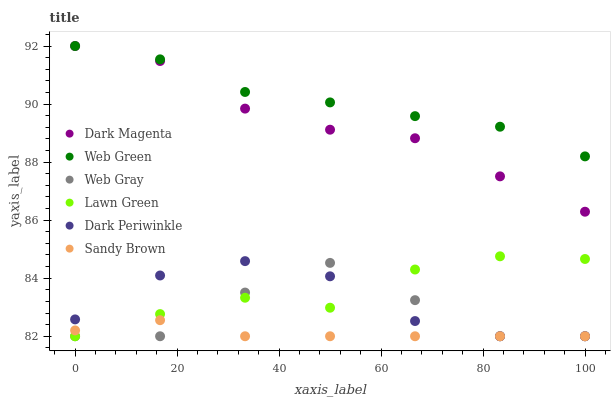Does Sandy Brown have the minimum area under the curve?
Answer yes or no. Yes. Does Web Green have the maximum area under the curve?
Answer yes or no. Yes. Does Web Gray have the minimum area under the curve?
Answer yes or no. No. Does Web Gray have the maximum area under the curve?
Answer yes or no. No. Is Sandy Brown the smoothest?
Answer yes or no. Yes. Is Web Gray the roughest?
Answer yes or no. Yes. Is Dark Magenta the smoothest?
Answer yes or no. No. Is Dark Magenta the roughest?
Answer yes or no. No. Does Lawn Green have the lowest value?
Answer yes or no. Yes. Does Dark Magenta have the lowest value?
Answer yes or no. No. Does Web Green have the highest value?
Answer yes or no. Yes. Does Web Gray have the highest value?
Answer yes or no. No. Is Dark Periwinkle less than Web Green?
Answer yes or no. Yes. Is Web Green greater than Lawn Green?
Answer yes or no. Yes. Does Sandy Brown intersect Dark Periwinkle?
Answer yes or no. Yes. Is Sandy Brown less than Dark Periwinkle?
Answer yes or no. No. Is Sandy Brown greater than Dark Periwinkle?
Answer yes or no. No. Does Dark Periwinkle intersect Web Green?
Answer yes or no. No. 